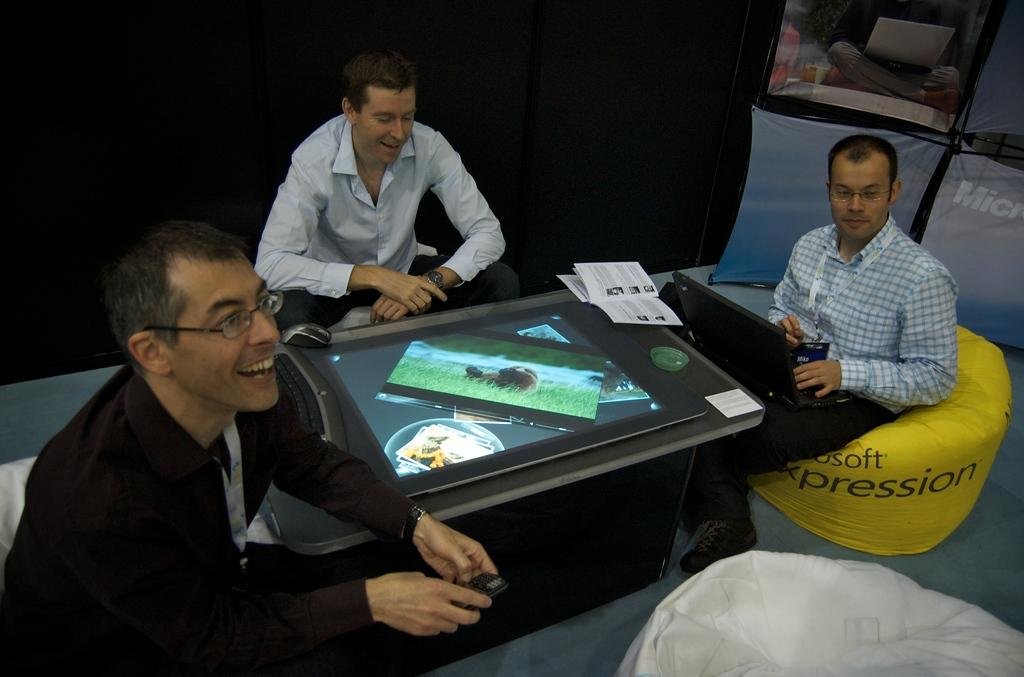How many people are in the image? There are three persons in the image. What are the persons doing in the image? The persons are sitting in front of a table. Can you describe the appearance of one of the persons? One person is wearing spectacles and a black shirt. What objects can be seen on the table in the image? There is a screen, a keyboard, a mouse, and a book on the table. What type of van is parked next to the table in the image? There is no van present in the image; it only shows three persons sitting in front of a table with various objects. 